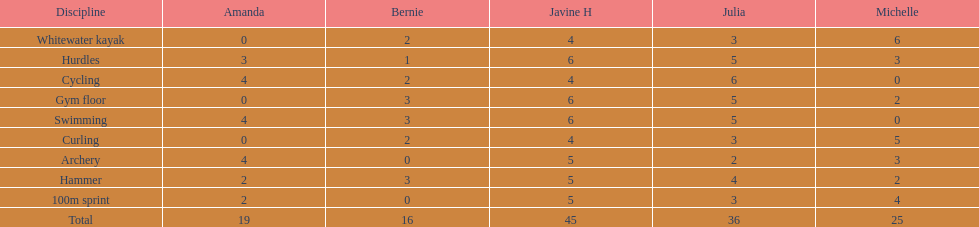Who reached their best result in cycling? Julia. 